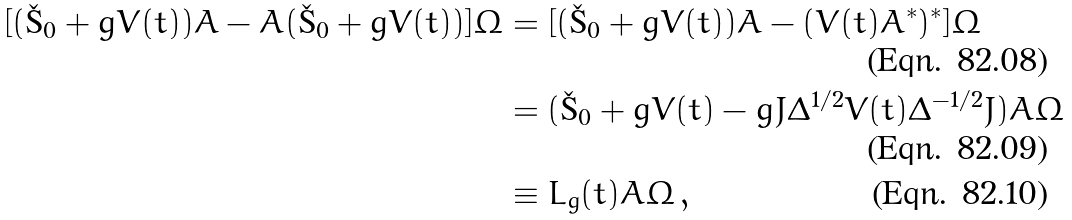Convert formula to latex. <formula><loc_0><loc_0><loc_500><loc_500>[ ( \L _ { 0 } + g V ( t ) ) A - A ( \L _ { 0 } + g V ( t ) ) ] \Omega & = [ ( \L _ { 0 } + g V ( t ) ) A - ( V ( t ) A ^ { * } ) ^ { * } ] \Omega \\ & = ( \L _ { 0 } + g V ( t ) - g J \Delta ^ { 1 / 2 } V ( t ) \Delta ^ { - 1 / 2 } J ) A \Omega \\ & \equiv L _ { g } ( t ) A \Omega \, ,</formula> 